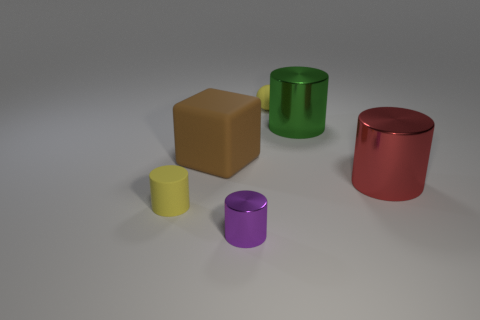What number of other things are the same color as the sphere?
Your response must be concise. 1. There is a yellow matte thing left of the tiny thing that is behind the small thing that is left of the purple metal cylinder; what is its size?
Your response must be concise. Small. There is a small purple cylinder; are there any metal cylinders on the right side of it?
Your answer should be very brief. Yes. Is the size of the green metallic object the same as the yellow rubber object to the left of the tiny metallic cylinder?
Make the answer very short. No. There is a thing that is both right of the yellow sphere and in front of the brown matte block; what is its shape?
Ensure brevity in your answer.  Cylinder. There is a yellow matte object left of the yellow ball; is it the same size as the metal cylinder that is left of the sphere?
Your answer should be very brief. Yes. There is a big object that is the same material as the yellow ball; what shape is it?
Offer a very short reply. Cube. Is there anything else that has the same shape as the big brown thing?
Your response must be concise. No. What is the color of the big thing that is to the left of the tiny yellow matte object that is to the right of the cylinder in front of the yellow cylinder?
Offer a terse response. Brown. Is the number of small metallic cylinders right of the big red metallic thing less than the number of big matte blocks behind the green cylinder?
Offer a very short reply. No. 